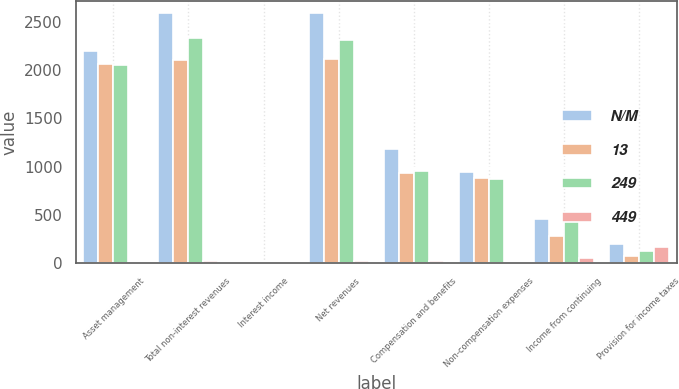Convert chart. <chart><loc_0><loc_0><loc_500><loc_500><stacked_bar_chart><ecel><fcel>Asset management<fcel>Total non-interest revenues<fcel>Interest income<fcel>Net revenues<fcel>Compensation and benefits<fcel>Non-compensation expenses<fcel>Income from continuing<fcel>Provision for income taxes<nl><fcel>N/M<fcel>2196<fcel>2586<fcel>4<fcel>2586<fcel>1181<fcel>949<fcel>456<fcel>201<nl><fcel>13<fcel>2063<fcel>2108<fcel>5<fcel>2112<fcel>937<fcel>888<fcel>287<fcel>75<nl><fcel>249<fcel>2049<fcel>2331<fcel>2<fcel>2315<fcel>954<fcel>869<fcel>492<fcel>128<nl><fcel>449<fcel>6<fcel>23<fcel>20<fcel>22<fcel>26<fcel>7<fcel>59<fcel>168<nl></chart> 